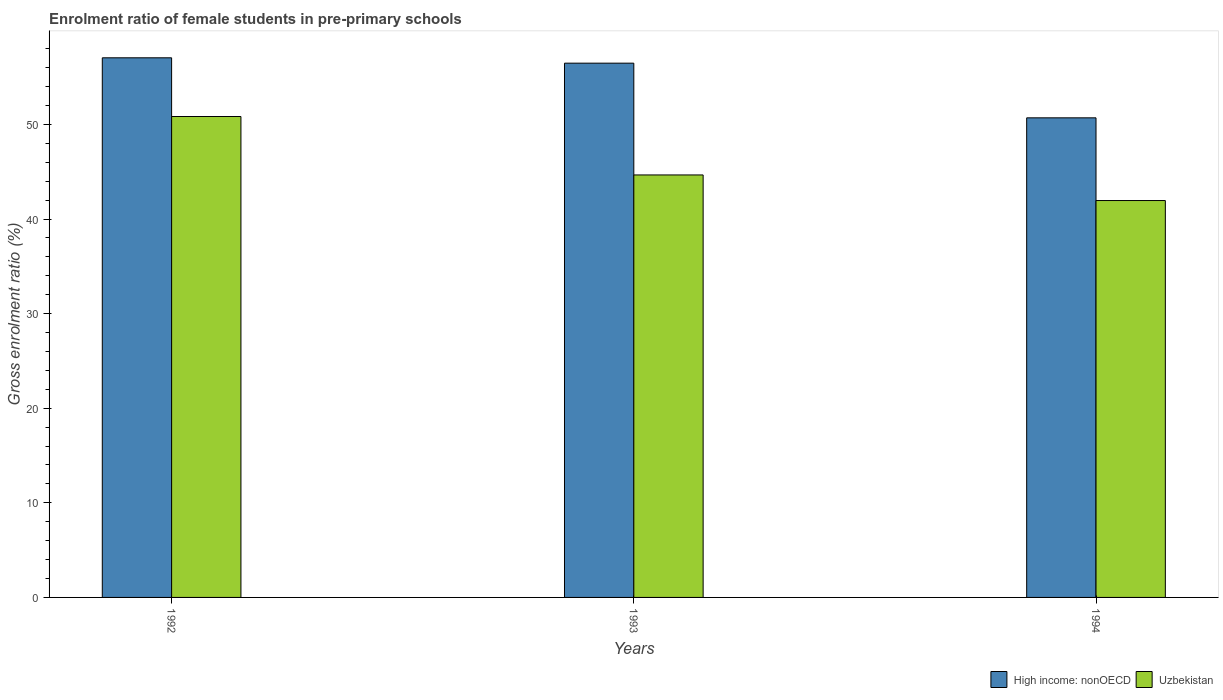How many groups of bars are there?
Your answer should be compact. 3. In how many cases, is the number of bars for a given year not equal to the number of legend labels?
Offer a terse response. 0. What is the enrolment ratio of female students in pre-primary schools in Uzbekistan in 1994?
Your answer should be very brief. 41.95. Across all years, what is the maximum enrolment ratio of female students in pre-primary schools in Uzbekistan?
Provide a succinct answer. 50.84. Across all years, what is the minimum enrolment ratio of female students in pre-primary schools in High income: nonOECD?
Give a very brief answer. 50.7. In which year was the enrolment ratio of female students in pre-primary schools in Uzbekistan minimum?
Give a very brief answer. 1994. What is the total enrolment ratio of female students in pre-primary schools in High income: nonOECD in the graph?
Ensure brevity in your answer.  164.21. What is the difference between the enrolment ratio of female students in pre-primary schools in Uzbekistan in 1992 and that in 1993?
Your answer should be compact. 6.18. What is the difference between the enrolment ratio of female students in pre-primary schools in Uzbekistan in 1992 and the enrolment ratio of female students in pre-primary schools in High income: nonOECD in 1994?
Provide a succinct answer. 0.14. What is the average enrolment ratio of female students in pre-primary schools in Uzbekistan per year?
Provide a short and direct response. 45.82. In the year 1994, what is the difference between the enrolment ratio of female students in pre-primary schools in High income: nonOECD and enrolment ratio of female students in pre-primary schools in Uzbekistan?
Keep it short and to the point. 8.74. What is the ratio of the enrolment ratio of female students in pre-primary schools in Uzbekistan in 1993 to that in 1994?
Provide a short and direct response. 1.06. Is the difference between the enrolment ratio of female students in pre-primary schools in High income: nonOECD in 1992 and 1993 greater than the difference between the enrolment ratio of female students in pre-primary schools in Uzbekistan in 1992 and 1993?
Make the answer very short. No. What is the difference between the highest and the second highest enrolment ratio of female students in pre-primary schools in High income: nonOECD?
Make the answer very short. 0.57. What is the difference between the highest and the lowest enrolment ratio of female students in pre-primary schools in Uzbekistan?
Your response must be concise. 8.88. Is the sum of the enrolment ratio of female students in pre-primary schools in High income: nonOECD in 1993 and 1994 greater than the maximum enrolment ratio of female students in pre-primary schools in Uzbekistan across all years?
Your response must be concise. Yes. What does the 1st bar from the left in 1994 represents?
Ensure brevity in your answer.  High income: nonOECD. What does the 2nd bar from the right in 1992 represents?
Keep it short and to the point. High income: nonOECD. Are all the bars in the graph horizontal?
Ensure brevity in your answer.  No. How many years are there in the graph?
Keep it short and to the point. 3. What is the difference between two consecutive major ticks on the Y-axis?
Offer a terse response. 10. Does the graph contain grids?
Your answer should be very brief. No. What is the title of the graph?
Provide a short and direct response. Enrolment ratio of female students in pre-primary schools. What is the Gross enrolment ratio (%) in High income: nonOECD in 1992?
Your response must be concise. 57.04. What is the Gross enrolment ratio (%) of Uzbekistan in 1992?
Your answer should be very brief. 50.84. What is the Gross enrolment ratio (%) in High income: nonOECD in 1993?
Offer a very short reply. 56.48. What is the Gross enrolment ratio (%) of Uzbekistan in 1993?
Keep it short and to the point. 44.66. What is the Gross enrolment ratio (%) of High income: nonOECD in 1994?
Offer a very short reply. 50.7. What is the Gross enrolment ratio (%) of Uzbekistan in 1994?
Your answer should be very brief. 41.95. Across all years, what is the maximum Gross enrolment ratio (%) in High income: nonOECD?
Provide a short and direct response. 57.04. Across all years, what is the maximum Gross enrolment ratio (%) of Uzbekistan?
Your answer should be compact. 50.84. Across all years, what is the minimum Gross enrolment ratio (%) of High income: nonOECD?
Ensure brevity in your answer.  50.7. Across all years, what is the minimum Gross enrolment ratio (%) in Uzbekistan?
Make the answer very short. 41.95. What is the total Gross enrolment ratio (%) of High income: nonOECD in the graph?
Offer a very short reply. 164.21. What is the total Gross enrolment ratio (%) in Uzbekistan in the graph?
Keep it short and to the point. 137.45. What is the difference between the Gross enrolment ratio (%) of High income: nonOECD in 1992 and that in 1993?
Offer a very short reply. 0.57. What is the difference between the Gross enrolment ratio (%) of Uzbekistan in 1992 and that in 1993?
Offer a very short reply. 6.18. What is the difference between the Gross enrolment ratio (%) of High income: nonOECD in 1992 and that in 1994?
Your answer should be very brief. 6.34. What is the difference between the Gross enrolment ratio (%) in Uzbekistan in 1992 and that in 1994?
Make the answer very short. 8.88. What is the difference between the Gross enrolment ratio (%) of High income: nonOECD in 1993 and that in 1994?
Offer a terse response. 5.78. What is the difference between the Gross enrolment ratio (%) in Uzbekistan in 1993 and that in 1994?
Give a very brief answer. 2.7. What is the difference between the Gross enrolment ratio (%) in High income: nonOECD in 1992 and the Gross enrolment ratio (%) in Uzbekistan in 1993?
Provide a short and direct response. 12.38. What is the difference between the Gross enrolment ratio (%) in High income: nonOECD in 1992 and the Gross enrolment ratio (%) in Uzbekistan in 1994?
Provide a succinct answer. 15.09. What is the difference between the Gross enrolment ratio (%) of High income: nonOECD in 1993 and the Gross enrolment ratio (%) of Uzbekistan in 1994?
Provide a short and direct response. 14.52. What is the average Gross enrolment ratio (%) in High income: nonOECD per year?
Your answer should be very brief. 54.74. What is the average Gross enrolment ratio (%) of Uzbekistan per year?
Give a very brief answer. 45.82. In the year 1992, what is the difference between the Gross enrolment ratio (%) in High income: nonOECD and Gross enrolment ratio (%) in Uzbekistan?
Give a very brief answer. 6.21. In the year 1993, what is the difference between the Gross enrolment ratio (%) in High income: nonOECD and Gross enrolment ratio (%) in Uzbekistan?
Provide a succinct answer. 11.82. In the year 1994, what is the difference between the Gross enrolment ratio (%) of High income: nonOECD and Gross enrolment ratio (%) of Uzbekistan?
Your response must be concise. 8.74. What is the ratio of the Gross enrolment ratio (%) in High income: nonOECD in 1992 to that in 1993?
Ensure brevity in your answer.  1.01. What is the ratio of the Gross enrolment ratio (%) in Uzbekistan in 1992 to that in 1993?
Make the answer very short. 1.14. What is the ratio of the Gross enrolment ratio (%) of High income: nonOECD in 1992 to that in 1994?
Your answer should be compact. 1.13. What is the ratio of the Gross enrolment ratio (%) in Uzbekistan in 1992 to that in 1994?
Make the answer very short. 1.21. What is the ratio of the Gross enrolment ratio (%) in High income: nonOECD in 1993 to that in 1994?
Offer a terse response. 1.11. What is the ratio of the Gross enrolment ratio (%) in Uzbekistan in 1993 to that in 1994?
Provide a short and direct response. 1.06. What is the difference between the highest and the second highest Gross enrolment ratio (%) in High income: nonOECD?
Your answer should be compact. 0.57. What is the difference between the highest and the second highest Gross enrolment ratio (%) in Uzbekistan?
Make the answer very short. 6.18. What is the difference between the highest and the lowest Gross enrolment ratio (%) in High income: nonOECD?
Offer a terse response. 6.34. What is the difference between the highest and the lowest Gross enrolment ratio (%) in Uzbekistan?
Your answer should be compact. 8.88. 